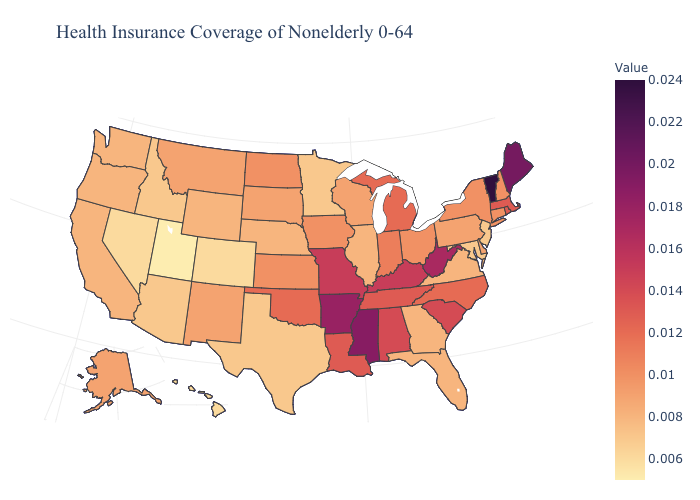Among the states that border Wyoming , does Nebraska have the lowest value?
Short answer required. No. Does New Jersey have the lowest value in the Northeast?
Write a very short answer. Yes. Which states have the lowest value in the West?
Short answer required. Utah. Does Vermont have the lowest value in the Northeast?
Quick response, please. No. Among the states that border Tennessee , does Georgia have the lowest value?
Quick response, please. Yes. 